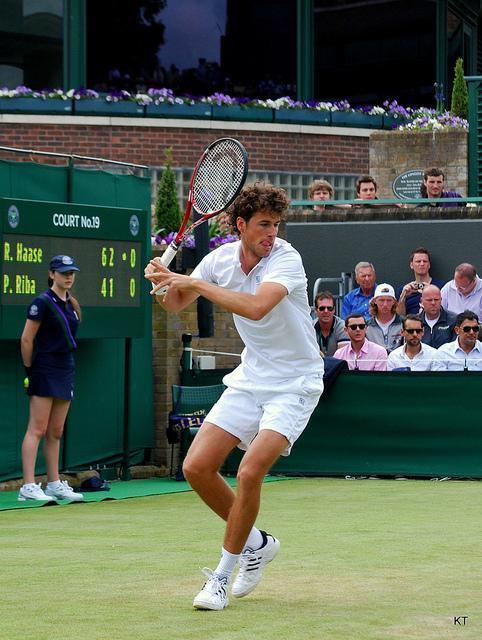How many people are wearing sunglasses?
Give a very brief answer. 4. How many people can be seen?
Give a very brief answer. 3. 